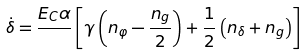Convert formula to latex. <formula><loc_0><loc_0><loc_500><loc_500>\dot { \delta } = \frac { E _ { C } \alpha } { } \left [ { \gamma \left ( { n _ { \varphi } - \frac { n _ { g } } { 2 } } \right ) + \frac { 1 } { 2 } \left ( { n _ { \delta } + n _ { g } } \right ) } \right ]</formula> 